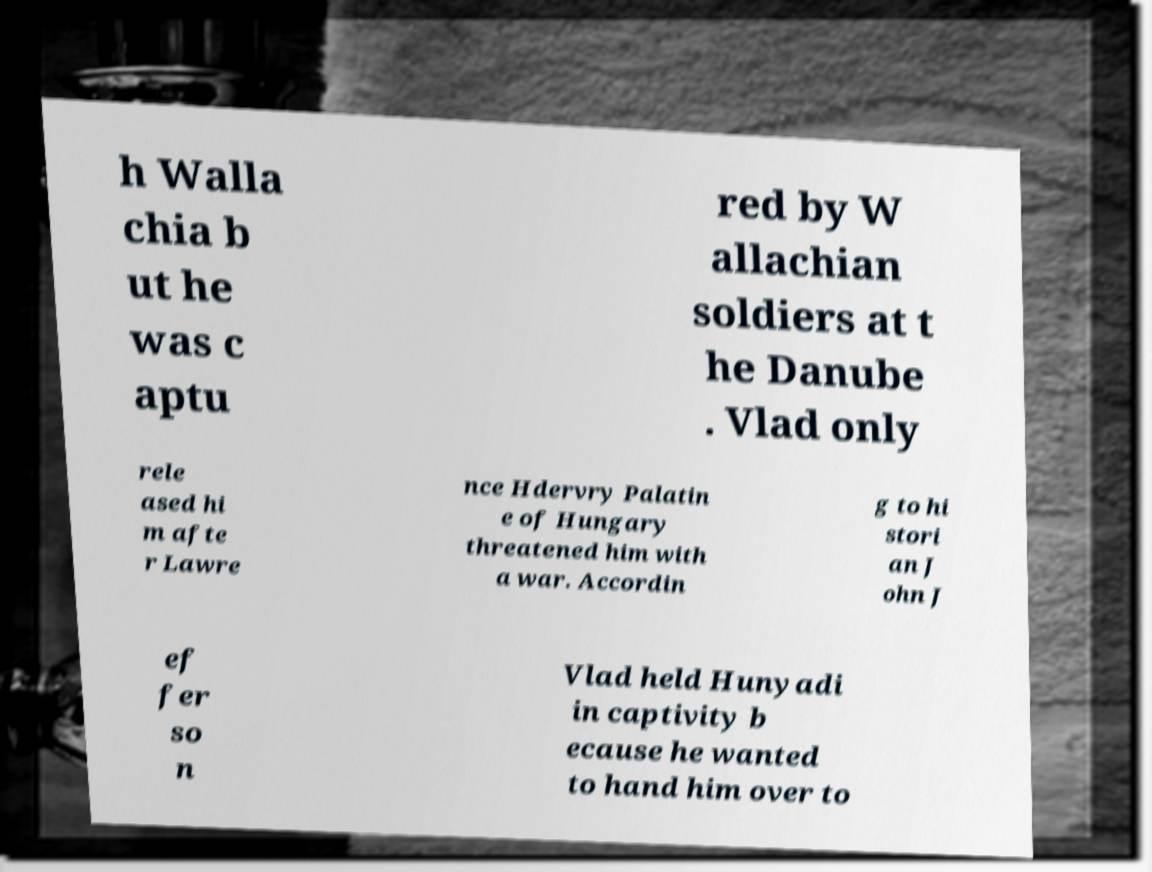Please read and relay the text visible in this image. What does it say? h Walla chia b ut he was c aptu red by W allachian soldiers at t he Danube . Vlad only rele ased hi m afte r Lawre nce Hdervry Palatin e of Hungary threatened him with a war. Accordin g to hi stori an J ohn J ef fer so n Vlad held Hunyadi in captivity b ecause he wanted to hand him over to 